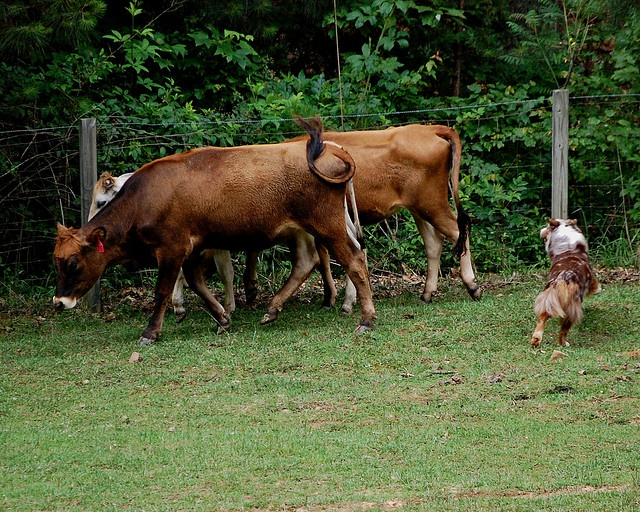Describe the objects in this image and their specific colors. I can see cow in black, maroon, and gray tones, cow in black, maroon, brown, and gray tones, and dog in black, maroon, darkgray, and gray tones in this image. 